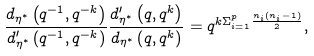<formula> <loc_0><loc_0><loc_500><loc_500>\frac { d _ { \eta ^ { \ast } } \left ( q ^ { - 1 } , q ^ { - k } \right ) } { d _ { \eta ^ { \ast } } ^ { \prime } \left ( q ^ { - 1 } , q ^ { - k } \right ) } \frac { d _ { \eta ^ { \ast } } ^ { \prime } \left ( q , q ^ { k } \right ) } { d _ { \eta ^ { \ast } } \left ( q , q ^ { k } \right ) } = q ^ { k \Sigma _ { i = 1 } ^ { p } \frac { n _ { i } ( n _ { i } - 1 ) } { 2 } } ,</formula> 